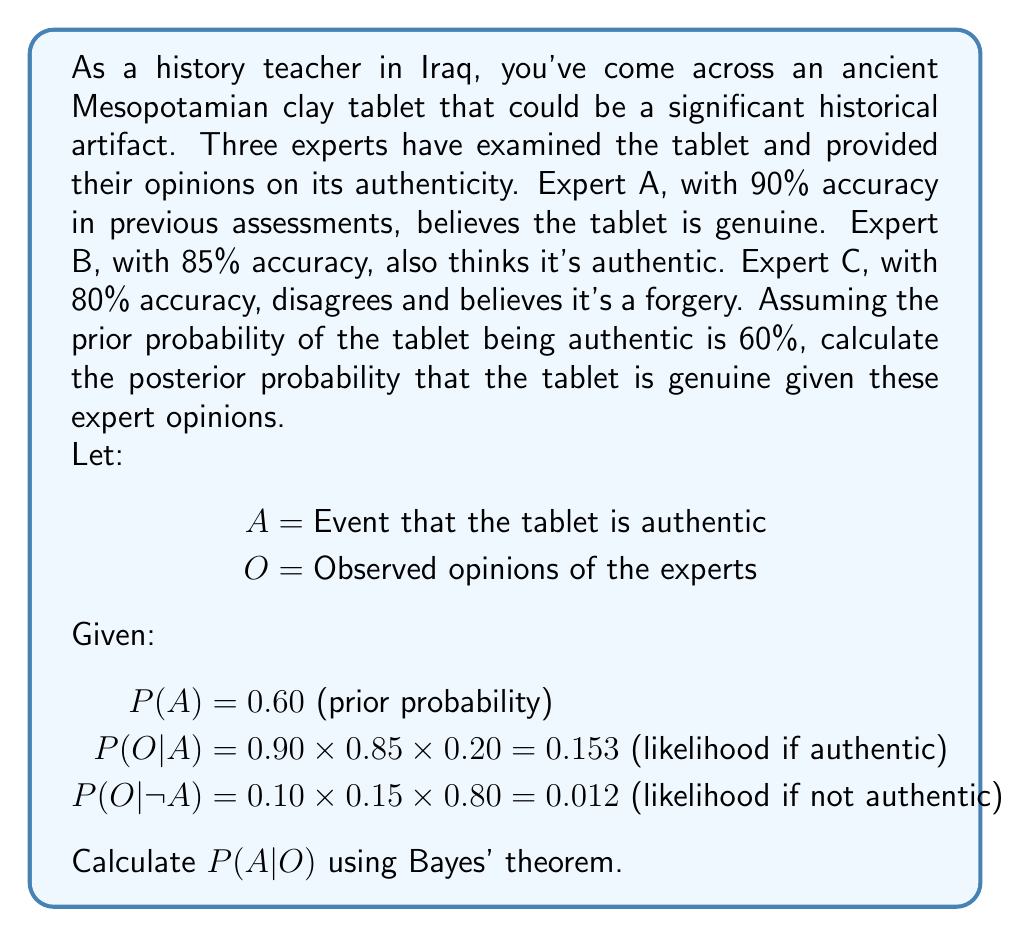Solve this math problem. To solve this problem, we'll use Bayes' theorem:

$$P(A|O) = \frac{P(O|A) \times P(A)}{P(O)}$$

1. We're given $P(A) = 0.60$ and $P(O|A) = 0.153$.

2. We need to calculate $P(O)$ using the law of total probability:
   $$P(O) = P(O|A) \times P(A) + P(O|\neg A) \times P(\neg A)$$
   
   $$P(O) = 0.153 \times 0.60 + 0.012 \times 0.40 = 0.0918 + 0.0048 = 0.0966$$

3. Now we can apply Bayes' theorem:

   $$P(A|O) = \frac{0.153 \times 0.60}{0.0966} = \frac{0.0918}{0.0966} \approx 0.9502$$

4. Convert to a percentage:
   $$0.9502 \times 100\% = 95.02\%$$

Therefore, given the expert opinions, the posterior probability that the tablet is authentic is approximately 95.02%.
Answer: 95.02% 